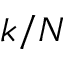Convert formula to latex. <formula><loc_0><loc_0><loc_500><loc_500>k / N</formula> 